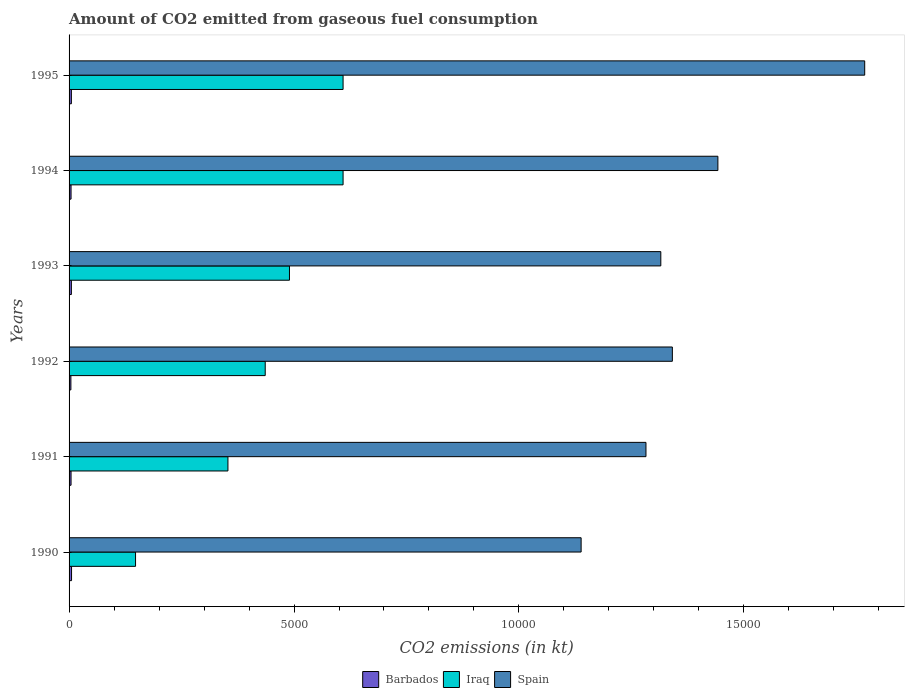How many different coloured bars are there?
Keep it short and to the point. 3. How many bars are there on the 1st tick from the top?
Offer a terse response. 3. What is the label of the 6th group of bars from the top?
Your answer should be very brief. 1990. What is the amount of CO2 emitted in Barbados in 1994?
Your response must be concise. 44. Across all years, what is the maximum amount of CO2 emitted in Iraq?
Your answer should be very brief. 6090.89. Across all years, what is the minimum amount of CO2 emitted in Spain?
Your answer should be very brief. 1.14e+04. In which year was the amount of CO2 emitted in Spain maximum?
Make the answer very short. 1995. What is the total amount of CO2 emitted in Barbados in the graph?
Your answer should be very brief. 286.03. What is the difference between the amount of CO2 emitted in Iraq in 1991 and that in 1992?
Your response must be concise. -828.74. What is the difference between the amount of CO2 emitted in Iraq in 1994 and the amount of CO2 emitted in Barbados in 1992?
Make the answer very short. 6050.55. What is the average amount of CO2 emitted in Spain per year?
Ensure brevity in your answer.  1.38e+04. In the year 1991, what is the difference between the amount of CO2 emitted in Spain and amount of CO2 emitted in Iraq?
Provide a short and direct response. 9292.18. What is the ratio of the amount of CO2 emitted in Barbados in 1990 to that in 1994?
Give a very brief answer. 1.25. Is the amount of CO2 emitted in Barbados in 1991 less than that in 1994?
Ensure brevity in your answer.  No. Is the difference between the amount of CO2 emitted in Spain in 1991 and 1995 greater than the difference between the amount of CO2 emitted in Iraq in 1991 and 1995?
Provide a short and direct response. No. What is the difference between the highest and the second highest amount of CO2 emitted in Iraq?
Offer a terse response. 0. What is the difference between the highest and the lowest amount of CO2 emitted in Spain?
Your response must be concise. 6303.57. What does the 3rd bar from the top in 1990 represents?
Give a very brief answer. Barbados. What does the 1st bar from the bottom in 1994 represents?
Give a very brief answer. Barbados. Are all the bars in the graph horizontal?
Ensure brevity in your answer.  Yes. What is the difference between two consecutive major ticks on the X-axis?
Keep it short and to the point. 5000. Are the values on the major ticks of X-axis written in scientific E-notation?
Your answer should be very brief. No. Does the graph contain grids?
Your response must be concise. No. Where does the legend appear in the graph?
Offer a very short reply. Bottom center. How many legend labels are there?
Provide a short and direct response. 3. What is the title of the graph?
Ensure brevity in your answer.  Amount of CO2 emitted from gaseous fuel consumption. Does "Philippines" appear as one of the legend labels in the graph?
Make the answer very short. No. What is the label or title of the X-axis?
Offer a terse response. CO2 emissions (in kt). What is the label or title of the Y-axis?
Offer a very short reply. Years. What is the CO2 emissions (in kt) in Barbados in 1990?
Your answer should be very brief. 55.01. What is the CO2 emissions (in kt) of Iraq in 1990?
Provide a succinct answer. 1477.8. What is the CO2 emissions (in kt) in Spain in 1990?
Your response must be concise. 1.14e+04. What is the CO2 emissions (in kt) of Barbados in 1991?
Offer a very short reply. 44. What is the CO2 emissions (in kt) of Iraq in 1991?
Give a very brief answer. 3531.32. What is the CO2 emissions (in kt) of Spain in 1991?
Your answer should be compact. 1.28e+04. What is the CO2 emissions (in kt) in Barbados in 1992?
Your answer should be very brief. 40.34. What is the CO2 emissions (in kt) of Iraq in 1992?
Ensure brevity in your answer.  4360.06. What is the CO2 emissions (in kt) in Spain in 1992?
Offer a terse response. 1.34e+04. What is the CO2 emissions (in kt) in Barbados in 1993?
Keep it short and to the point. 51.34. What is the CO2 emissions (in kt) in Iraq in 1993?
Ensure brevity in your answer.  4899.11. What is the CO2 emissions (in kt) in Spain in 1993?
Give a very brief answer. 1.32e+04. What is the CO2 emissions (in kt) in Barbados in 1994?
Give a very brief answer. 44. What is the CO2 emissions (in kt) in Iraq in 1994?
Keep it short and to the point. 6090.89. What is the CO2 emissions (in kt) in Spain in 1994?
Provide a succinct answer. 1.44e+04. What is the CO2 emissions (in kt) of Barbados in 1995?
Give a very brief answer. 51.34. What is the CO2 emissions (in kt) in Iraq in 1995?
Provide a short and direct response. 6090.89. What is the CO2 emissions (in kt) in Spain in 1995?
Make the answer very short. 1.77e+04. Across all years, what is the maximum CO2 emissions (in kt) of Barbados?
Your answer should be very brief. 55.01. Across all years, what is the maximum CO2 emissions (in kt) in Iraq?
Offer a very short reply. 6090.89. Across all years, what is the maximum CO2 emissions (in kt) of Spain?
Keep it short and to the point. 1.77e+04. Across all years, what is the minimum CO2 emissions (in kt) in Barbados?
Provide a short and direct response. 40.34. Across all years, what is the minimum CO2 emissions (in kt) in Iraq?
Your answer should be very brief. 1477.8. Across all years, what is the minimum CO2 emissions (in kt) in Spain?
Offer a very short reply. 1.14e+04. What is the total CO2 emissions (in kt) in Barbados in the graph?
Offer a very short reply. 286.03. What is the total CO2 emissions (in kt) in Iraq in the graph?
Ensure brevity in your answer.  2.65e+04. What is the total CO2 emissions (in kt) in Spain in the graph?
Provide a succinct answer. 8.29e+04. What is the difference between the CO2 emissions (in kt) in Barbados in 1990 and that in 1991?
Give a very brief answer. 11. What is the difference between the CO2 emissions (in kt) in Iraq in 1990 and that in 1991?
Give a very brief answer. -2053.52. What is the difference between the CO2 emissions (in kt) in Spain in 1990 and that in 1991?
Give a very brief answer. -1441.13. What is the difference between the CO2 emissions (in kt) of Barbados in 1990 and that in 1992?
Your answer should be very brief. 14.67. What is the difference between the CO2 emissions (in kt) in Iraq in 1990 and that in 1992?
Your answer should be compact. -2882.26. What is the difference between the CO2 emissions (in kt) of Spain in 1990 and that in 1992?
Provide a short and direct response. -2027.85. What is the difference between the CO2 emissions (in kt) in Barbados in 1990 and that in 1993?
Provide a short and direct response. 3.67. What is the difference between the CO2 emissions (in kt) of Iraq in 1990 and that in 1993?
Give a very brief answer. -3421.31. What is the difference between the CO2 emissions (in kt) in Spain in 1990 and that in 1993?
Ensure brevity in your answer.  -1771.16. What is the difference between the CO2 emissions (in kt) of Barbados in 1990 and that in 1994?
Offer a very short reply. 11. What is the difference between the CO2 emissions (in kt) of Iraq in 1990 and that in 1994?
Your response must be concise. -4613.09. What is the difference between the CO2 emissions (in kt) of Spain in 1990 and that in 1994?
Offer a terse response. -3039.94. What is the difference between the CO2 emissions (in kt) of Barbados in 1990 and that in 1995?
Offer a terse response. 3.67. What is the difference between the CO2 emissions (in kt) of Iraq in 1990 and that in 1995?
Your answer should be very brief. -4613.09. What is the difference between the CO2 emissions (in kt) in Spain in 1990 and that in 1995?
Provide a short and direct response. -6303.57. What is the difference between the CO2 emissions (in kt) in Barbados in 1991 and that in 1992?
Provide a succinct answer. 3.67. What is the difference between the CO2 emissions (in kt) in Iraq in 1991 and that in 1992?
Provide a succinct answer. -828.74. What is the difference between the CO2 emissions (in kt) of Spain in 1991 and that in 1992?
Ensure brevity in your answer.  -586.72. What is the difference between the CO2 emissions (in kt) in Barbados in 1991 and that in 1993?
Give a very brief answer. -7.33. What is the difference between the CO2 emissions (in kt) in Iraq in 1991 and that in 1993?
Your answer should be very brief. -1367.79. What is the difference between the CO2 emissions (in kt) of Spain in 1991 and that in 1993?
Offer a very short reply. -330.03. What is the difference between the CO2 emissions (in kt) in Barbados in 1991 and that in 1994?
Provide a succinct answer. 0. What is the difference between the CO2 emissions (in kt) of Iraq in 1991 and that in 1994?
Ensure brevity in your answer.  -2559.57. What is the difference between the CO2 emissions (in kt) in Spain in 1991 and that in 1994?
Offer a terse response. -1598.81. What is the difference between the CO2 emissions (in kt) in Barbados in 1991 and that in 1995?
Your answer should be compact. -7.33. What is the difference between the CO2 emissions (in kt) in Iraq in 1991 and that in 1995?
Ensure brevity in your answer.  -2559.57. What is the difference between the CO2 emissions (in kt) in Spain in 1991 and that in 1995?
Your answer should be compact. -4862.44. What is the difference between the CO2 emissions (in kt) in Barbados in 1992 and that in 1993?
Make the answer very short. -11. What is the difference between the CO2 emissions (in kt) in Iraq in 1992 and that in 1993?
Offer a terse response. -539.05. What is the difference between the CO2 emissions (in kt) in Spain in 1992 and that in 1993?
Keep it short and to the point. 256.69. What is the difference between the CO2 emissions (in kt) of Barbados in 1992 and that in 1994?
Keep it short and to the point. -3.67. What is the difference between the CO2 emissions (in kt) of Iraq in 1992 and that in 1994?
Your answer should be compact. -1730.82. What is the difference between the CO2 emissions (in kt) in Spain in 1992 and that in 1994?
Ensure brevity in your answer.  -1012.09. What is the difference between the CO2 emissions (in kt) in Barbados in 1992 and that in 1995?
Keep it short and to the point. -11. What is the difference between the CO2 emissions (in kt) in Iraq in 1992 and that in 1995?
Make the answer very short. -1730.82. What is the difference between the CO2 emissions (in kt) of Spain in 1992 and that in 1995?
Your answer should be very brief. -4275.72. What is the difference between the CO2 emissions (in kt) of Barbados in 1993 and that in 1994?
Give a very brief answer. 7.33. What is the difference between the CO2 emissions (in kt) in Iraq in 1993 and that in 1994?
Make the answer very short. -1191.78. What is the difference between the CO2 emissions (in kt) of Spain in 1993 and that in 1994?
Make the answer very short. -1268.78. What is the difference between the CO2 emissions (in kt) of Barbados in 1993 and that in 1995?
Ensure brevity in your answer.  0. What is the difference between the CO2 emissions (in kt) of Iraq in 1993 and that in 1995?
Keep it short and to the point. -1191.78. What is the difference between the CO2 emissions (in kt) of Spain in 1993 and that in 1995?
Keep it short and to the point. -4532.41. What is the difference between the CO2 emissions (in kt) of Barbados in 1994 and that in 1995?
Offer a terse response. -7.33. What is the difference between the CO2 emissions (in kt) in Iraq in 1994 and that in 1995?
Your answer should be compact. 0. What is the difference between the CO2 emissions (in kt) of Spain in 1994 and that in 1995?
Ensure brevity in your answer.  -3263.63. What is the difference between the CO2 emissions (in kt) in Barbados in 1990 and the CO2 emissions (in kt) in Iraq in 1991?
Provide a succinct answer. -3476.32. What is the difference between the CO2 emissions (in kt) in Barbados in 1990 and the CO2 emissions (in kt) in Spain in 1991?
Make the answer very short. -1.28e+04. What is the difference between the CO2 emissions (in kt) of Iraq in 1990 and the CO2 emissions (in kt) of Spain in 1991?
Offer a very short reply. -1.13e+04. What is the difference between the CO2 emissions (in kt) in Barbados in 1990 and the CO2 emissions (in kt) in Iraq in 1992?
Ensure brevity in your answer.  -4305.06. What is the difference between the CO2 emissions (in kt) in Barbados in 1990 and the CO2 emissions (in kt) in Spain in 1992?
Provide a succinct answer. -1.34e+04. What is the difference between the CO2 emissions (in kt) of Iraq in 1990 and the CO2 emissions (in kt) of Spain in 1992?
Your answer should be compact. -1.19e+04. What is the difference between the CO2 emissions (in kt) in Barbados in 1990 and the CO2 emissions (in kt) in Iraq in 1993?
Your answer should be very brief. -4844.11. What is the difference between the CO2 emissions (in kt) in Barbados in 1990 and the CO2 emissions (in kt) in Spain in 1993?
Your answer should be very brief. -1.31e+04. What is the difference between the CO2 emissions (in kt) in Iraq in 1990 and the CO2 emissions (in kt) in Spain in 1993?
Your answer should be compact. -1.17e+04. What is the difference between the CO2 emissions (in kt) of Barbados in 1990 and the CO2 emissions (in kt) of Iraq in 1994?
Your response must be concise. -6035.88. What is the difference between the CO2 emissions (in kt) of Barbados in 1990 and the CO2 emissions (in kt) of Spain in 1994?
Offer a very short reply. -1.44e+04. What is the difference between the CO2 emissions (in kt) of Iraq in 1990 and the CO2 emissions (in kt) of Spain in 1994?
Your answer should be compact. -1.29e+04. What is the difference between the CO2 emissions (in kt) of Barbados in 1990 and the CO2 emissions (in kt) of Iraq in 1995?
Offer a terse response. -6035.88. What is the difference between the CO2 emissions (in kt) of Barbados in 1990 and the CO2 emissions (in kt) of Spain in 1995?
Provide a short and direct response. -1.76e+04. What is the difference between the CO2 emissions (in kt) in Iraq in 1990 and the CO2 emissions (in kt) in Spain in 1995?
Provide a short and direct response. -1.62e+04. What is the difference between the CO2 emissions (in kt) in Barbados in 1991 and the CO2 emissions (in kt) in Iraq in 1992?
Ensure brevity in your answer.  -4316.06. What is the difference between the CO2 emissions (in kt) of Barbados in 1991 and the CO2 emissions (in kt) of Spain in 1992?
Ensure brevity in your answer.  -1.34e+04. What is the difference between the CO2 emissions (in kt) of Iraq in 1991 and the CO2 emissions (in kt) of Spain in 1992?
Your answer should be very brief. -9878.9. What is the difference between the CO2 emissions (in kt) of Barbados in 1991 and the CO2 emissions (in kt) of Iraq in 1993?
Keep it short and to the point. -4855.11. What is the difference between the CO2 emissions (in kt) of Barbados in 1991 and the CO2 emissions (in kt) of Spain in 1993?
Keep it short and to the point. -1.31e+04. What is the difference between the CO2 emissions (in kt) of Iraq in 1991 and the CO2 emissions (in kt) of Spain in 1993?
Offer a very short reply. -9622.21. What is the difference between the CO2 emissions (in kt) in Barbados in 1991 and the CO2 emissions (in kt) in Iraq in 1994?
Make the answer very short. -6046.88. What is the difference between the CO2 emissions (in kt) of Barbados in 1991 and the CO2 emissions (in kt) of Spain in 1994?
Offer a terse response. -1.44e+04. What is the difference between the CO2 emissions (in kt) of Iraq in 1991 and the CO2 emissions (in kt) of Spain in 1994?
Keep it short and to the point. -1.09e+04. What is the difference between the CO2 emissions (in kt) of Barbados in 1991 and the CO2 emissions (in kt) of Iraq in 1995?
Your answer should be compact. -6046.88. What is the difference between the CO2 emissions (in kt) in Barbados in 1991 and the CO2 emissions (in kt) in Spain in 1995?
Keep it short and to the point. -1.76e+04. What is the difference between the CO2 emissions (in kt) of Iraq in 1991 and the CO2 emissions (in kt) of Spain in 1995?
Your response must be concise. -1.42e+04. What is the difference between the CO2 emissions (in kt) of Barbados in 1992 and the CO2 emissions (in kt) of Iraq in 1993?
Your answer should be compact. -4858.77. What is the difference between the CO2 emissions (in kt) in Barbados in 1992 and the CO2 emissions (in kt) in Spain in 1993?
Ensure brevity in your answer.  -1.31e+04. What is the difference between the CO2 emissions (in kt) of Iraq in 1992 and the CO2 emissions (in kt) of Spain in 1993?
Your answer should be very brief. -8793.47. What is the difference between the CO2 emissions (in kt) of Barbados in 1992 and the CO2 emissions (in kt) of Iraq in 1994?
Make the answer very short. -6050.55. What is the difference between the CO2 emissions (in kt) in Barbados in 1992 and the CO2 emissions (in kt) in Spain in 1994?
Provide a short and direct response. -1.44e+04. What is the difference between the CO2 emissions (in kt) in Iraq in 1992 and the CO2 emissions (in kt) in Spain in 1994?
Give a very brief answer. -1.01e+04. What is the difference between the CO2 emissions (in kt) of Barbados in 1992 and the CO2 emissions (in kt) of Iraq in 1995?
Offer a terse response. -6050.55. What is the difference between the CO2 emissions (in kt) in Barbados in 1992 and the CO2 emissions (in kt) in Spain in 1995?
Your answer should be compact. -1.76e+04. What is the difference between the CO2 emissions (in kt) of Iraq in 1992 and the CO2 emissions (in kt) of Spain in 1995?
Provide a short and direct response. -1.33e+04. What is the difference between the CO2 emissions (in kt) in Barbados in 1993 and the CO2 emissions (in kt) in Iraq in 1994?
Make the answer very short. -6039.55. What is the difference between the CO2 emissions (in kt) of Barbados in 1993 and the CO2 emissions (in kt) of Spain in 1994?
Offer a terse response. -1.44e+04. What is the difference between the CO2 emissions (in kt) in Iraq in 1993 and the CO2 emissions (in kt) in Spain in 1994?
Provide a succinct answer. -9523.2. What is the difference between the CO2 emissions (in kt) of Barbados in 1993 and the CO2 emissions (in kt) of Iraq in 1995?
Give a very brief answer. -6039.55. What is the difference between the CO2 emissions (in kt) of Barbados in 1993 and the CO2 emissions (in kt) of Spain in 1995?
Your answer should be very brief. -1.76e+04. What is the difference between the CO2 emissions (in kt) in Iraq in 1993 and the CO2 emissions (in kt) in Spain in 1995?
Ensure brevity in your answer.  -1.28e+04. What is the difference between the CO2 emissions (in kt) in Barbados in 1994 and the CO2 emissions (in kt) in Iraq in 1995?
Provide a succinct answer. -6046.88. What is the difference between the CO2 emissions (in kt) in Barbados in 1994 and the CO2 emissions (in kt) in Spain in 1995?
Provide a short and direct response. -1.76e+04. What is the difference between the CO2 emissions (in kt) of Iraq in 1994 and the CO2 emissions (in kt) of Spain in 1995?
Give a very brief answer. -1.16e+04. What is the average CO2 emissions (in kt) in Barbados per year?
Your answer should be very brief. 47.67. What is the average CO2 emissions (in kt) in Iraq per year?
Your answer should be compact. 4408.35. What is the average CO2 emissions (in kt) of Spain per year?
Provide a succinct answer. 1.38e+04. In the year 1990, what is the difference between the CO2 emissions (in kt) of Barbados and CO2 emissions (in kt) of Iraq?
Your answer should be very brief. -1422.8. In the year 1990, what is the difference between the CO2 emissions (in kt) of Barbados and CO2 emissions (in kt) of Spain?
Provide a short and direct response. -1.13e+04. In the year 1990, what is the difference between the CO2 emissions (in kt) in Iraq and CO2 emissions (in kt) in Spain?
Make the answer very short. -9904.57. In the year 1991, what is the difference between the CO2 emissions (in kt) in Barbados and CO2 emissions (in kt) in Iraq?
Keep it short and to the point. -3487.32. In the year 1991, what is the difference between the CO2 emissions (in kt) of Barbados and CO2 emissions (in kt) of Spain?
Ensure brevity in your answer.  -1.28e+04. In the year 1991, what is the difference between the CO2 emissions (in kt) of Iraq and CO2 emissions (in kt) of Spain?
Make the answer very short. -9292.18. In the year 1992, what is the difference between the CO2 emissions (in kt) of Barbados and CO2 emissions (in kt) of Iraq?
Provide a succinct answer. -4319.73. In the year 1992, what is the difference between the CO2 emissions (in kt) in Barbados and CO2 emissions (in kt) in Spain?
Provide a succinct answer. -1.34e+04. In the year 1992, what is the difference between the CO2 emissions (in kt) in Iraq and CO2 emissions (in kt) in Spain?
Give a very brief answer. -9050.16. In the year 1993, what is the difference between the CO2 emissions (in kt) of Barbados and CO2 emissions (in kt) of Iraq?
Make the answer very short. -4847.77. In the year 1993, what is the difference between the CO2 emissions (in kt) of Barbados and CO2 emissions (in kt) of Spain?
Give a very brief answer. -1.31e+04. In the year 1993, what is the difference between the CO2 emissions (in kt) of Iraq and CO2 emissions (in kt) of Spain?
Make the answer very short. -8254.42. In the year 1994, what is the difference between the CO2 emissions (in kt) in Barbados and CO2 emissions (in kt) in Iraq?
Keep it short and to the point. -6046.88. In the year 1994, what is the difference between the CO2 emissions (in kt) of Barbados and CO2 emissions (in kt) of Spain?
Ensure brevity in your answer.  -1.44e+04. In the year 1994, what is the difference between the CO2 emissions (in kt) of Iraq and CO2 emissions (in kt) of Spain?
Provide a short and direct response. -8331.42. In the year 1995, what is the difference between the CO2 emissions (in kt) in Barbados and CO2 emissions (in kt) in Iraq?
Provide a short and direct response. -6039.55. In the year 1995, what is the difference between the CO2 emissions (in kt) in Barbados and CO2 emissions (in kt) in Spain?
Ensure brevity in your answer.  -1.76e+04. In the year 1995, what is the difference between the CO2 emissions (in kt) of Iraq and CO2 emissions (in kt) of Spain?
Give a very brief answer. -1.16e+04. What is the ratio of the CO2 emissions (in kt) in Barbados in 1990 to that in 1991?
Provide a succinct answer. 1.25. What is the ratio of the CO2 emissions (in kt) of Iraq in 1990 to that in 1991?
Your response must be concise. 0.42. What is the ratio of the CO2 emissions (in kt) of Spain in 1990 to that in 1991?
Provide a succinct answer. 0.89. What is the ratio of the CO2 emissions (in kt) of Barbados in 1990 to that in 1992?
Your answer should be compact. 1.36. What is the ratio of the CO2 emissions (in kt) in Iraq in 1990 to that in 1992?
Ensure brevity in your answer.  0.34. What is the ratio of the CO2 emissions (in kt) of Spain in 1990 to that in 1992?
Make the answer very short. 0.85. What is the ratio of the CO2 emissions (in kt) in Barbados in 1990 to that in 1993?
Provide a succinct answer. 1.07. What is the ratio of the CO2 emissions (in kt) of Iraq in 1990 to that in 1993?
Ensure brevity in your answer.  0.3. What is the ratio of the CO2 emissions (in kt) in Spain in 1990 to that in 1993?
Give a very brief answer. 0.87. What is the ratio of the CO2 emissions (in kt) in Iraq in 1990 to that in 1994?
Give a very brief answer. 0.24. What is the ratio of the CO2 emissions (in kt) in Spain in 1990 to that in 1994?
Ensure brevity in your answer.  0.79. What is the ratio of the CO2 emissions (in kt) of Barbados in 1990 to that in 1995?
Offer a very short reply. 1.07. What is the ratio of the CO2 emissions (in kt) of Iraq in 1990 to that in 1995?
Provide a succinct answer. 0.24. What is the ratio of the CO2 emissions (in kt) of Spain in 1990 to that in 1995?
Your answer should be very brief. 0.64. What is the ratio of the CO2 emissions (in kt) in Barbados in 1991 to that in 1992?
Your answer should be very brief. 1.09. What is the ratio of the CO2 emissions (in kt) in Iraq in 1991 to that in 1992?
Make the answer very short. 0.81. What is the ratio of the CO2 emissions (in kt) of Spain in 1991 to that in 1992?
Keep it short and to the point. 0.96. What is the ratio of the CO2 emissions (in kt) in Barbados in 1991 to that in 1993?
Make the answer very short. 0.86. What is the ratio of the CO2 emissions (in kt) of Iraq in 1991 to that in 1993?
Your answer should be compact. 0.72. What is the ratio of the CO2 emissions (in kt) in Spain in 1991 to that in 1993?
Your response must be concise. 0.97. What is the ratio of the CO2 emissions (in kt) of Barbados in 1991 to that in 1994?
Provide a short and direct response. 1. What is the ratio of the CO2 emissions (in kt) in Iraq in 1991 to that in 1994?
Keep it short and to the point. 0.58. What is the ratio of the CO2 emissions (in kt) in Spain in 1991 to that in 1994?
Provide a succinct answer. 0.89. What is the ratio of the CO2 emissions (in kt) in Barbados in 1991 to that in 1995?
Provide a succinct answer. 0.86. What is the ratio of the CO2 emissions (in kt) in Iraq in 1991 to that in 1995?
Keep it short and to the point. 0.58. What is the ratio of the CO2 emissions (in kt) of Spain in 1991 to that in 1995?
Offer a very short reply. 0.73. What is the ratio of the CO2 emissions (in kt) in Barbados in 1992 to that in 1993?
Provide a succinct answer. 0.79. What is the ratio of the CO2 emissions (in kt) in Iraq in 1992 to that in 1993?
Provide a short and direct response. 0.89. What is the ratio of the CO2 emissions (in kt) of Spain in 1992 to that in 1993?
Keep it short and to the point. 1.02. What is the ratio of the CO2 emissions (in kt) of Iraq in 1992 to that in 1994?
Offer a very short reply. 0.72. What is the ratio of the CO2 emissions (in kt) of Spain in 1992 to that in 1994?
Your response must be concise. 0.93. What is the ratio of the CO2 emissions (in kt) in Barbados in 1992 to that in 1995?
Your response must be concise. 0.79. What is the ratio of the CO2 emissions (in kt) of Iraq in 1992 to that in 1995?
Your answer should be very brief. 0.72. What is the ratio of the CO2 emissions (in kt) of Spain in 1992 to that in 1995?
Your answer should be compact. 0.76. What is the ratio of the CO2 emissions (in kt) of Iraq in 1993 to that in 1994?
Your answer should be very brief. 0.8. What is the ratio of the CO2 emissions (in kt) of Spain in 1993 to that in 1994?
Give a very brief answer. 0.91. What is the ratio of the CO2 emissions (in kt) in Iraq in 1993 to that in 1995?
Offer a very short reply. 0.8. What is the ratio of the CO2 emissions (in kt) of Spain in 1993 to that in 1995?
Provide a succinct answer. 0.74. What is the ratio of the CO2 emissions (in kt) in Spain in 1994 to that in 1995?
Offer a very short reply. 0.82. What is the difference between the highest and the second highest CO2 emissions (in kt) in Barbados?
Your answer should be compact. 3.67. What is the difference between the highest and the second highest CO2 emissions (in kt) in Spain?
Provide a succinct answer. 3263.63. What is the difference between the highest and the lowest CO2 emissions (in kt) in Barbados?
Offer a terse response. 14.67. What is the difference between the highest and the lowest CO2 emissions (in kt) in Iraq?
Make the answer very short. 4613.09. What is the difference between the highest and the lowest CO2 emissions (in kt) in Spain?
Offer a terse response. 6303.57. 